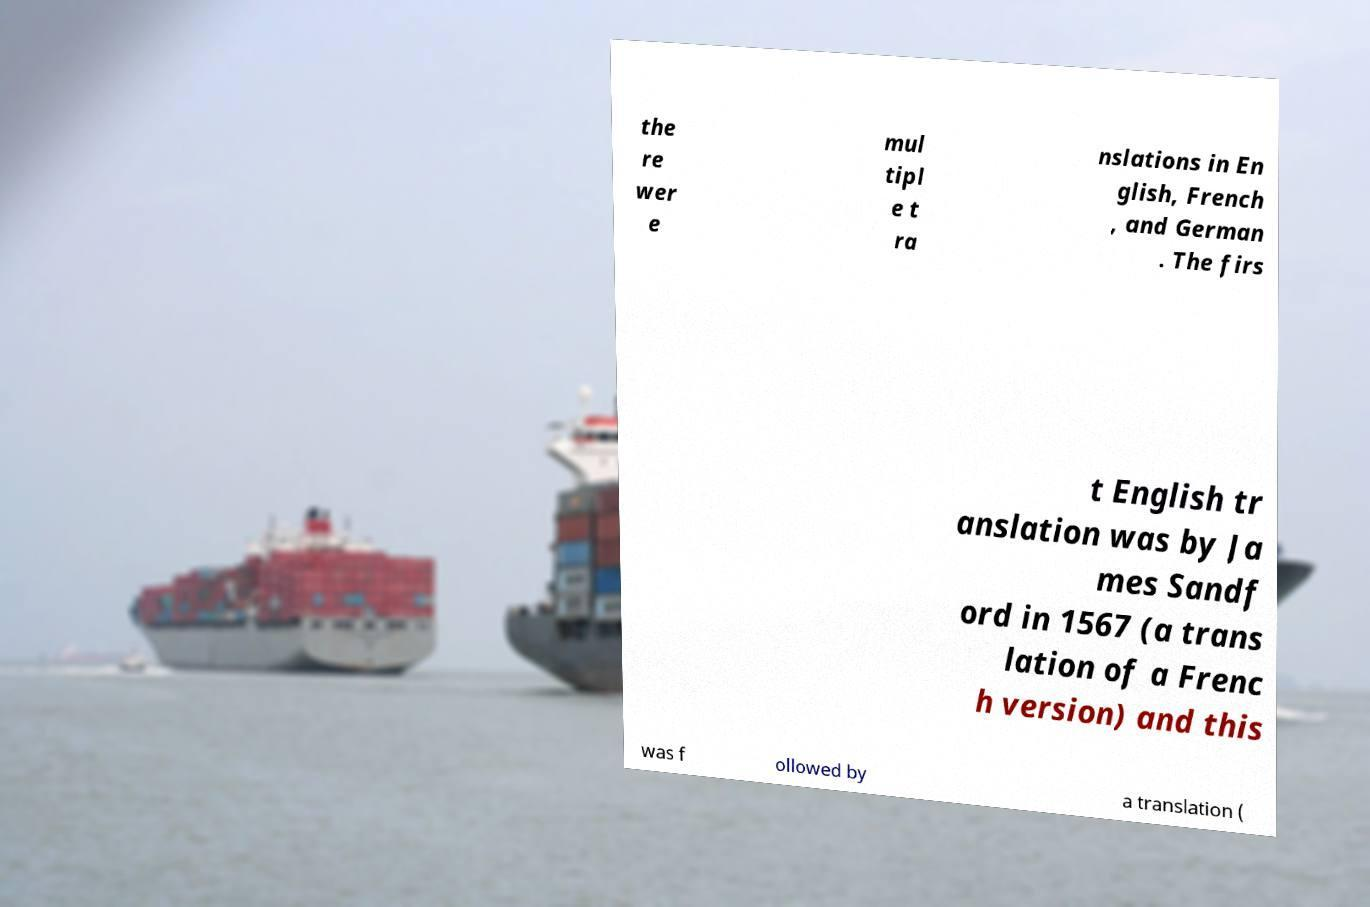Please read and relay the text visible in this image. What does it say? the re wer e mul tipl e t ra nslations in En glish, French , and German . The firs t English tr anslation was by Ja mes Sandf ord in 1567 (a trans lation of a Frenc h version) and this was f ollowed by a translation ( 